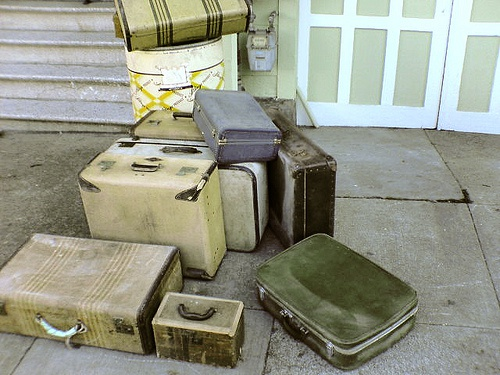Describe the objects in this image and their specific colors. I can see suitcase in gray, darkgray, olive, tan, and black tones, suitcase in gray, tan, beige, and lightgray tones, suitcase in gray, darkgreen, and black tones, suitcase in gray, black, darkgreen, and darkgray tones, and suitcase in gray, darkgreen, black, and darkgray tones in this image. 